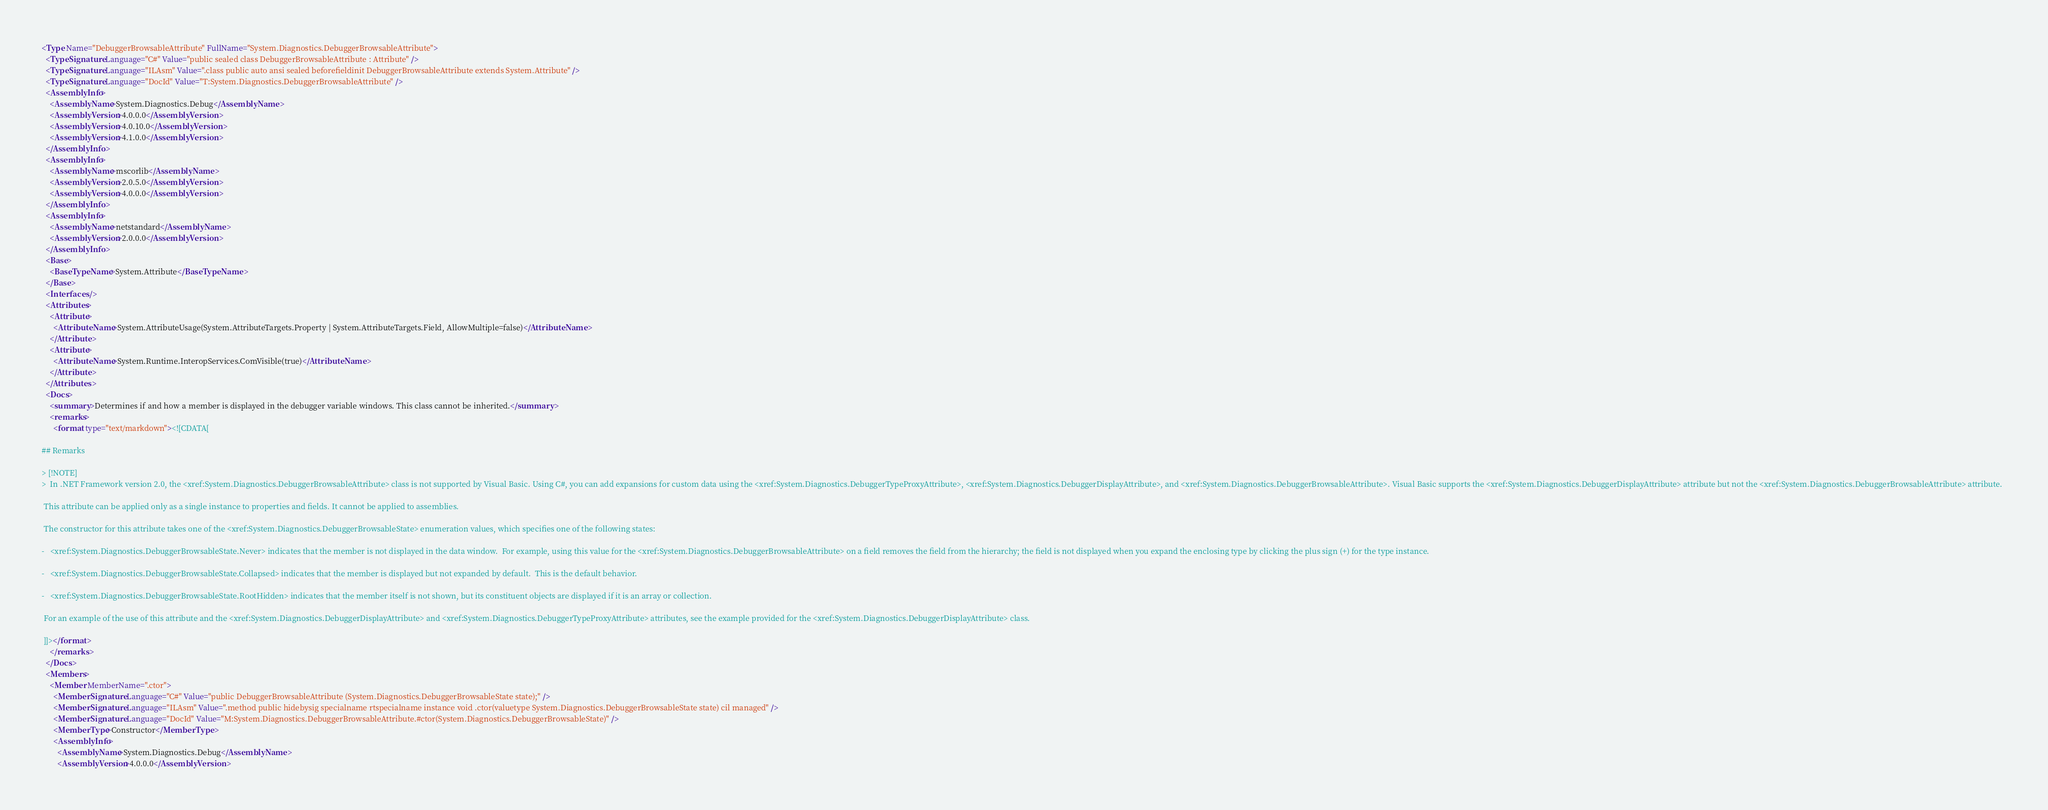Convert code to text. <code><loc_0><loc_0><loc_500><loc_500><_XML_><Type Name="DebuggerBrowsableAttribute" FullName="System.Diagnostics.DebuggerBrowsableAttribute">
  <TypeSignature Language="C#" Value="public sealed class DebuggerBrowsableAttribute : Attribute" />
  <TypeSignature Language="ILAsm" Value=".class public auto ansi sealed beforefieldinit DebuggerBrowsableAttribute extends System.Attribute" />
  <TypeSignature Language="DocId" Value="T:System.Diagnostics.DebuggerBrowsableAttribute" />
  <AssemblyInfo>
    <AssemblyName>System.Diagnostics.Debug</AssemblyName>
    <AssemblyVersion>4.0.0.0</AssemblyVersion>
    <AssemblyVersion>4.0.10.0</AssemblyVersion>
    <AssemblyVersion>4.1.0.0</AssemblyVersion>
  </AssemblyInfo>
  <AssemblyInfo>
    <AssemblyName>mscorlib</AssemblyName>
    <AssemblyVersion>2.0.5.0</AssemblyVersion>
    <AssemblyVersion>4.0.0.0</AssemblyVersion>
  </AssemblyInfo>
  <AssemblyInfo>
    <AssemblyName>netstandard</AssemblyName>
    <AssemblyVersion>2.0.0.0</AssemblyVersion>
  </AssemblyInfo>
  <Base>
    <BaseTypeName>System.Attribute</BaseTypeName>
  </Base>
  <Interfaces />
  <Attributes>
    <Attribute>
      <AttributeName>System.AttributeUsage(System.AttributeTargets.Property | System.AttributeTargets.Field, AllowMultiple=false)</AttributeName>
    </Attribute>
    <Attribute>
      <AttributeName>System.Runtime.InteropServices.ComVisible(true)</AttributeName>
    </Attribute>
  </Attributes>
  <Docs>
    <summary>Determines if and how a member is displayed in the debugger variable windows. This class cannot be inherited.</summary>
    <remarks>
      <format type="text/markdown"><![CDATA[  
  
## Remarks  
  
> [!NOTE]
>  In .NET Framework version 2.0, the <xref:System.Diagnostics.DebuggerBrowsableAttribute> class is not supported by Visual Basic. Using C#, you can add expansions for custom data using the <xref:System.Diagnostics.DebuggerTypeProxyAttribute>, <xref:System.Diagnostics.DebuggerDisplayAttribute>, and <xref:System.Diagnostics.DebuggerBrowsableAttribute>. Visual Basic supports the <xref:System.Diagnostics.DebuggerDisplayAttribute> attribute but not the <xref:System.Diagnostics.DebuggerBrowsableAttribute> attribute.  
  
 This attribute can be applied only as a single instance to properties and fields. It cannot be applied to assemblies.  
  
 The constructor for this attribute takes one of the <xref:System.Diagnostics.DebuggerBrowsableState> enumeration values, which specifies one of the following states:  
  
-   <xref:System.Diagnostics.DebuggerBrowsableState.Never> indicates that the member is not displayed in the data window.  For example, using this value for the <xref:System.Diagnostics.DebuggerBrowsableAttribute> on a field removes the field from the hierarchy; the field is not displayed when you expand the enclosing type by clicking the plus sign (+) for the type instance.  
  
-   <xref:System.Diagnostics.DebuggerBrowsableState.Collapsed> indicates that the member is displayed but not expanded by default.  This is the default behavior.  
  
-   <xref:System.Diagnostics.DebuggerBrowsableState.RootHidden> indicates that the member itself is not shown, but its constituent objects are displayed if it is an array or collection.  
  
 For an example of the use of this attribute and the <xref:System.Diagnostics.DebuggerDisplayAttribute> and <xref:System.Diagnostics.DebuggerTypeProxyAttribute> attributes, see the example provided for the <xref:System.Diagnostics.DebuggerDisplayAttribute> class.  
  
 ]]></format>
    </remarks>
  </Docs>
  <Members>
    <Member MemberName=".ctor">
      <MemberSignature Language="C#" Value="public DebuggerBrowsableAttribute (System.Diagnostics.DebuggerBrowsableState state);" />
      <MemberSignature Language="ILAsm" Value=".method public hidebysig specialname rtspecialname instance void .ctor(valuetype System.Diagnostics.DebuggerBrowsableState state) cil managed" />
      <MemberSignature Language="DocId" Value="M:System.Diagnostics.DebuggerBrowsableAttribute.#ctor(System.Diagnostics.DebuggerBrowsableState)" />
      <MemberType>Constructor</MemberType>
      <AssemblyInfo>
        <AssemblyName>System.Diagnostics.Debug</AssemblyName>
        <AssemblyVersion>4.0.0.0</AssemblyVersion></code> 